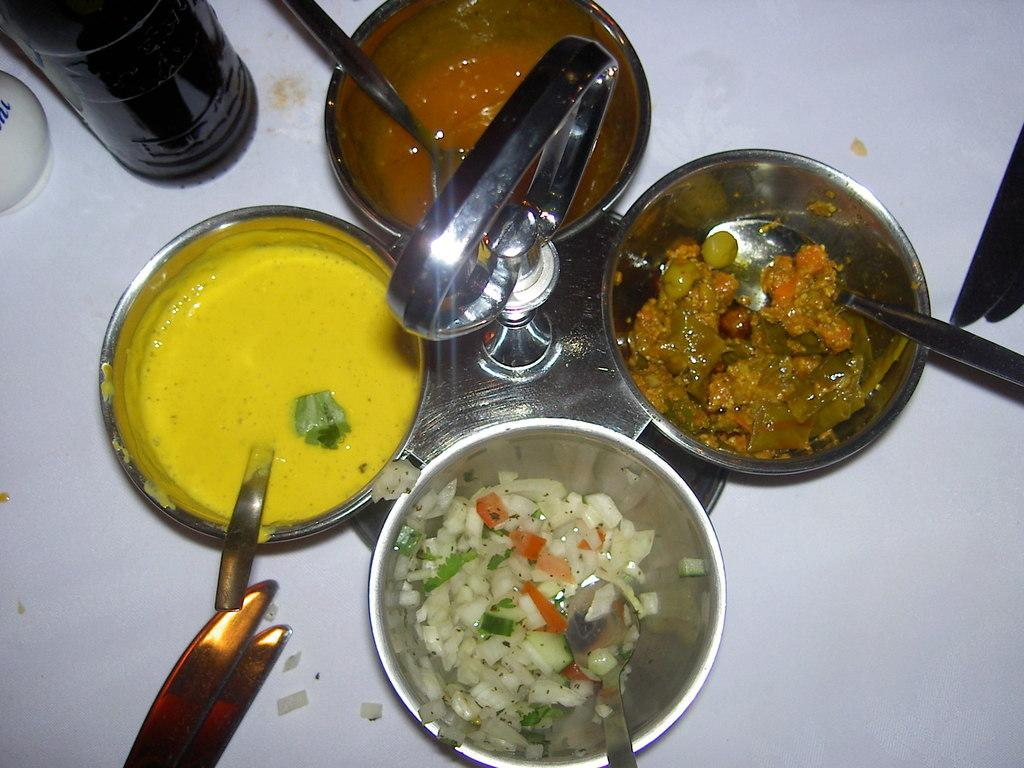What objects are used for eating or serving food in the image? There are utensils in the image. What is being held by the utensils in the image? There are food items in the utensils. What else can be seen in the image besides utensils and food items? There are additional items visible in the image. What color is the surface on which the utensils and food items are placed? There is a white surface in the image. What type of weather can be seen in the image? There is no weather visible in the image, as it is focused on utensils and food items placed on a white surface. 